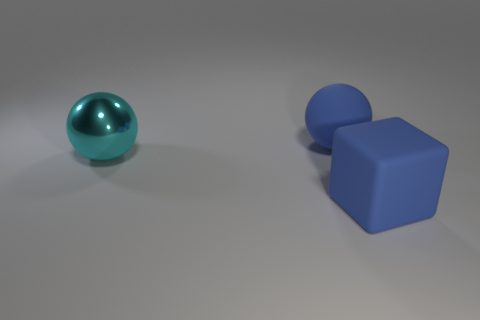Add 2 large spheres. How many objects exist? 5 Subtract all balls. How many objects are left? 1 Add 1 cyan spheres. How many cyan spheres exist? 2 Subtract 0 yellow balls. How many objects are left? 3 Subtract all blue matte balls. Subtract all big green cylinders. How many objects are left? 2 Add 1 cyan things. How many cyan things are left? 2 